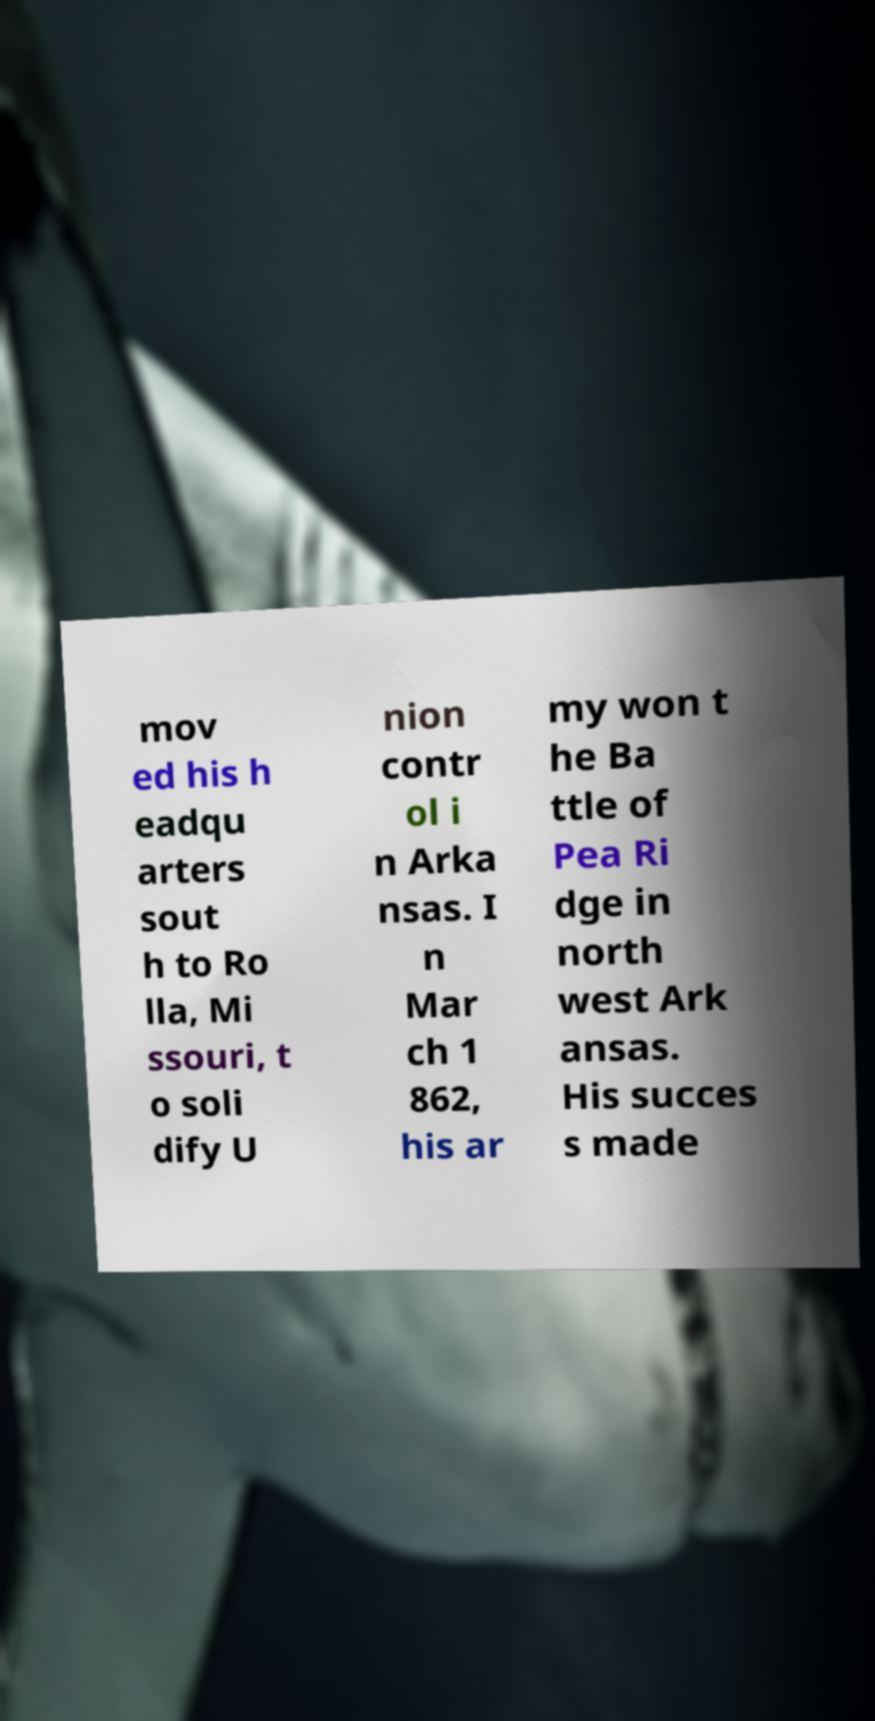Please identify and transcribe the text found in this image. mov ed his h eadqu arters sout h to Ro lla, Mi ssouri, t o soli dify U nion contr ol i n Arka nsas. I n Mar ch 1 862, his ar my won t he Ba ttle of Pea Ri dge in north west Ark ansas. His succes s made 